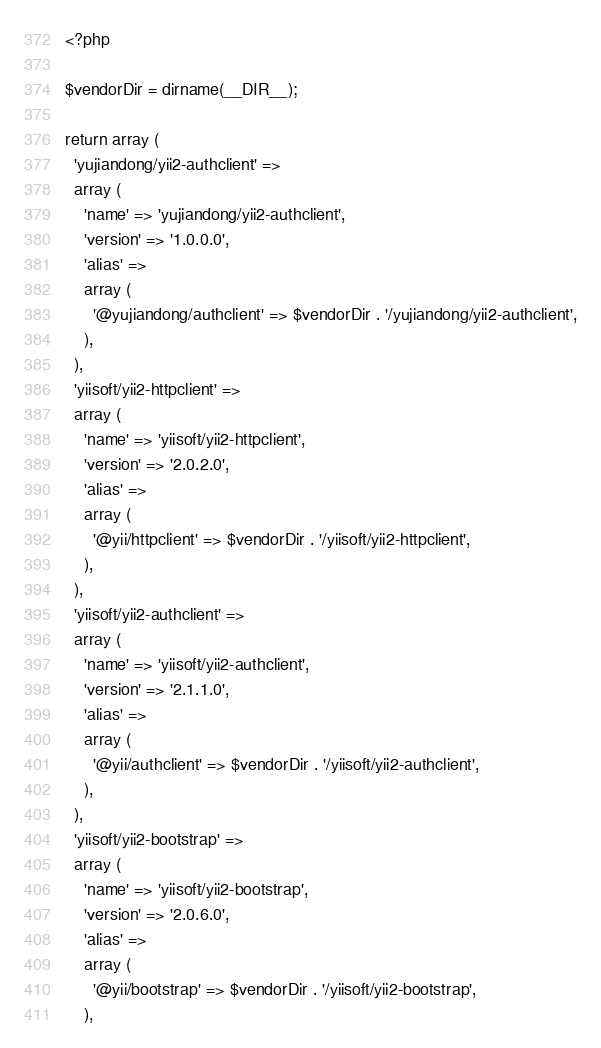<code> <loc_0><loc_0><loc_500><loc_500><_PHP_><?php

$vendorDir = dirname(__DIR__);

return array (
  'yujiandong/yii2-authclient' => 
  array (
    'name' => 'yujiandong/yii2-authclient',
    'version' => '1.0.0.0',
    'alias' => 
    array (
      '@yujiandong/authclient' => $vendorDir . '/yujiandong/yii2-authclient',
    ),
  ),
  'yiisoft/yii2-httpclient' => 
  array (
    'name' => 'yiisoft/yii2-httpclient',
    'version' => '2.0.2.0',
    'alias' => 
    array (
      '@yii/httpclient' => $vendorDir . '/yiisoft/yii2-httpclient',
    ),
  ),
  'yiisoft/yii2-authclient' => 
  array (
    'name' => 'yiisoft/yii2-authclient',
    'version' => '2.1.1.0',
    'alias' => 
    array (
      '@yii/authclient' => $vendorDir . '/yiisoft/yii2-authclient',
    ),
  ),
  'yiisoft/yii2-bootstrap' => 
  array (
    'name' => 'yiisoft/yii2-bootstrap',
    'version' => '2.0.6.0',
    'alias' => 
    array (
      '@yii/bootstrap' => $vendorDir . '/yiisoft/yii2-bootstrap',
    ),</code> 